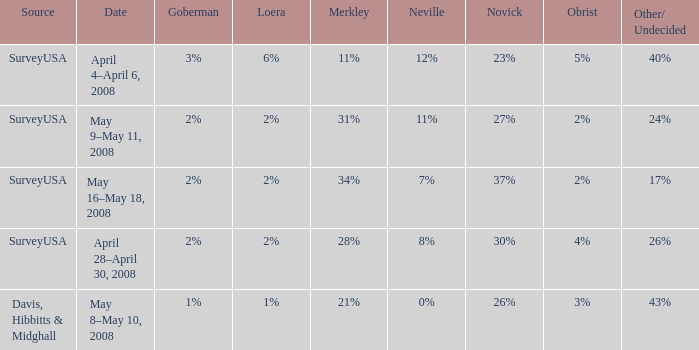Which Novick has a Source of surveyusa, and a Neville of 8%? 30%. 